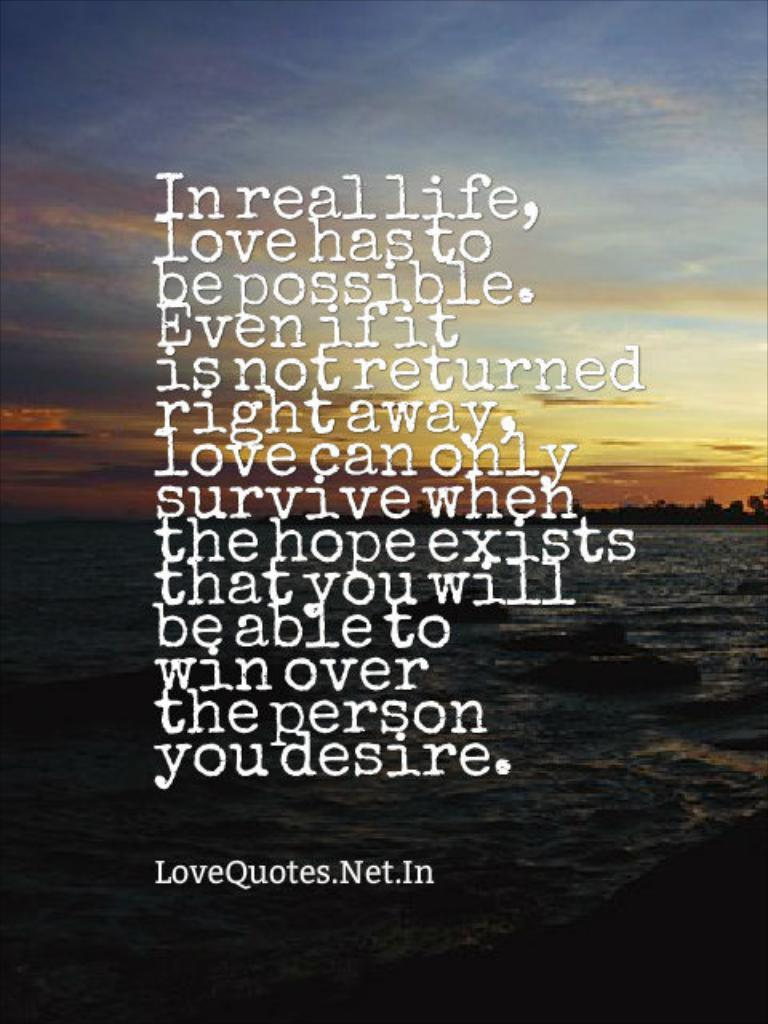<image>
Summarize the visual content of the image. A quote from LoveQuotes.Net.In is written on a picture of the ocean 